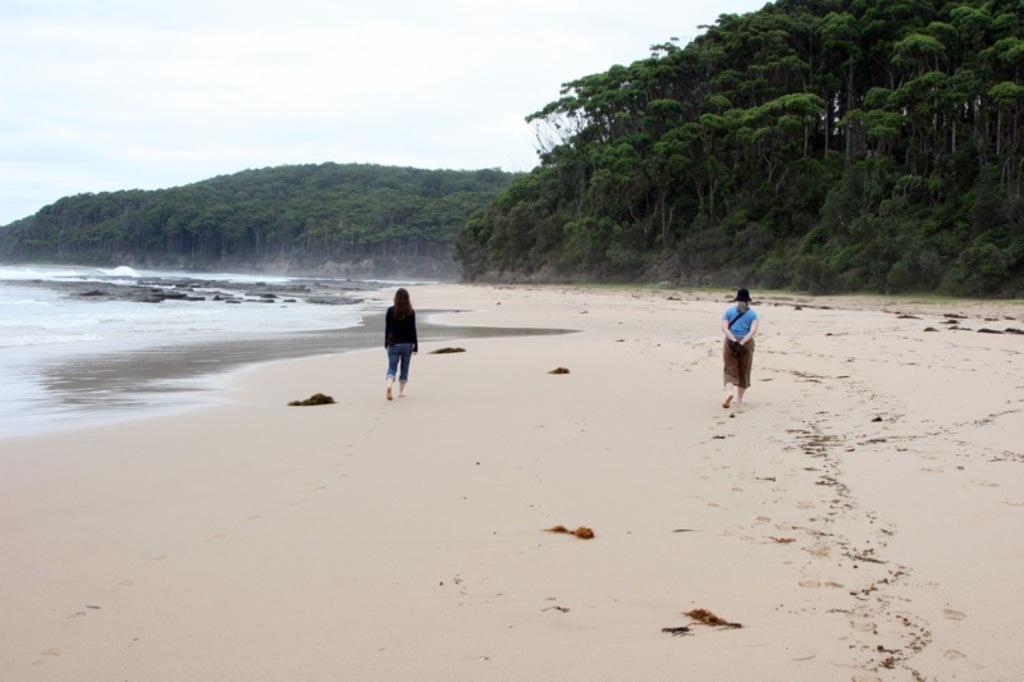How many people are in the image? There are two persons in the image. What are the persons doing in the image? The persons are walking on the seashore. What type of natural features can be seen in the image? There are rocks and trees visible in the image. What is visible at the top of the image? The sky is visible at the top of the image. Can you tell me how many snakes are slithering on the rocks in the image? There are no snakes visible in the image; it features two persons walking on the seashore with rocks and trees in the background. What type of kettle is present on the seashore in the image? There is no kettle present in the image; it only features two persons walking on the seashore with rocks and trees in the background. 